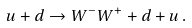<formula> <loc_0><loc_0><loc_500><loc_500>u + d \to W ^ { - } W ^ { + } + d + u \, .</formula> 